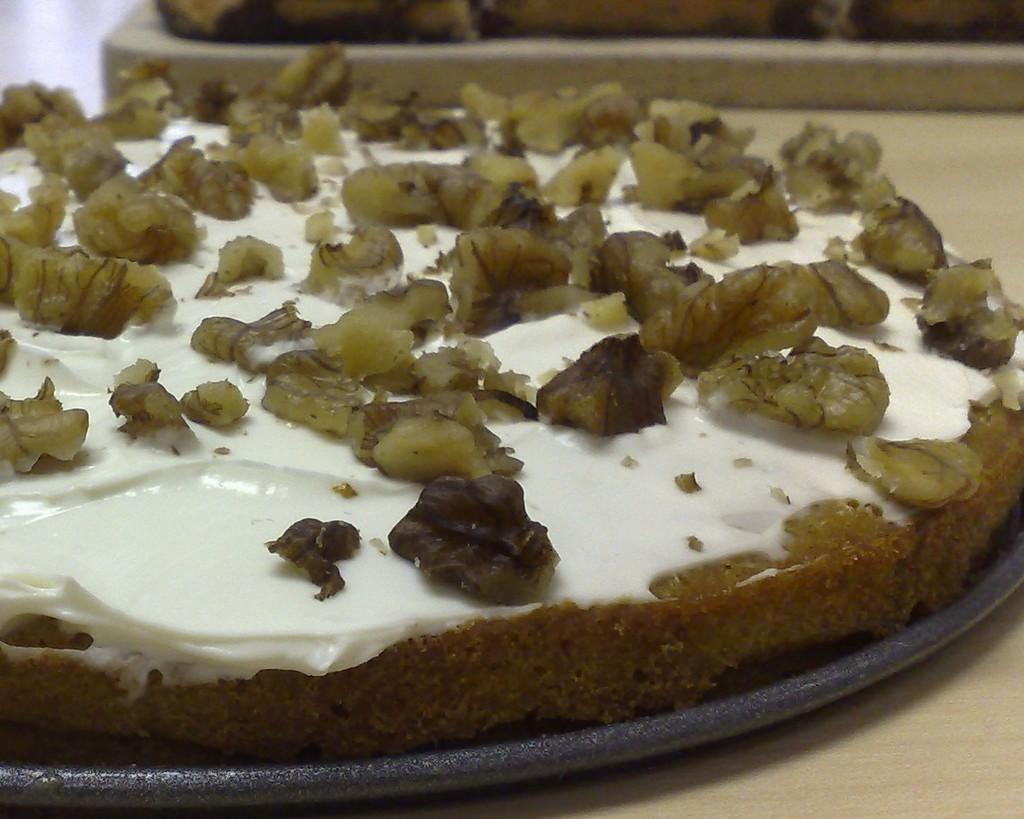What is on the black color pan in the image? There is food on a black color pan in the image. What is the color of the surface the pan is on? The pan is on a brown color surface. What colors can be seen in the food? The food has white, cream, and black colors. Are there any yokes visible in the image? There are no yokes present in the image. Can you hear any bells ringing in the image? There is no sound in the image, so it is not possible to hear any bells ringing. 